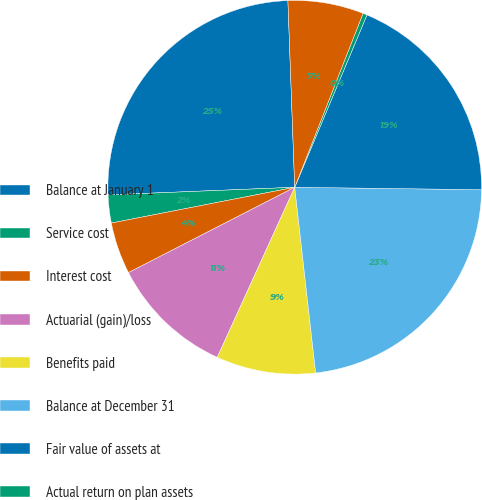Convert chart to OTSL. <chart><loc_0><loc_0><loc_500><loc_500><pie_chart><fcel>Balance at January 1<fcel>Service cost<fcel>Interest cost<fcel>Actuarial (gain)/loss<fcel>Benefits paid<fcel>Balance at December 31<fcel>Fair value of assets at<fcel>Actual return on plan assets<fcel>Employer contributions<nl><fcel>25.07%<fcel>2.42%<fcel>4.48%<fcel>10.65%<fcel>8.59%<fcel>23.01%<fcel>18.89%<fcel>0.36%<fcel>6.54%<nl></chart> 